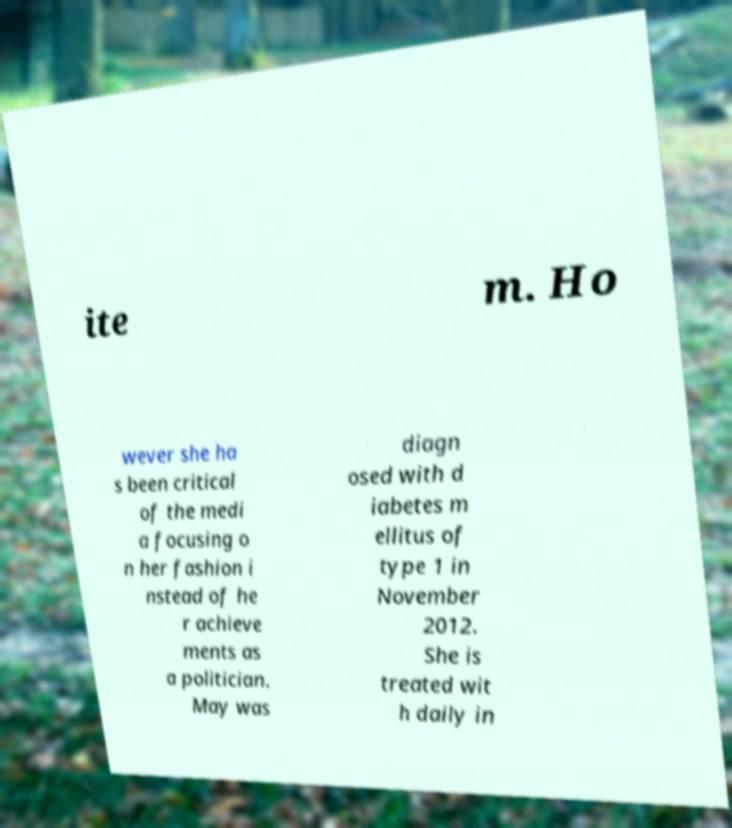What messages or text are displayed in this image? I need them in a readable, typed format. ite m. Ho wever she ha s been critical of the medi a focusing o n her fashion i nstead of he r achieve ments as a politician. May was diagn osed with d iabetes m ellitus of type 1 in November 2012. She is treated wit h daily in 